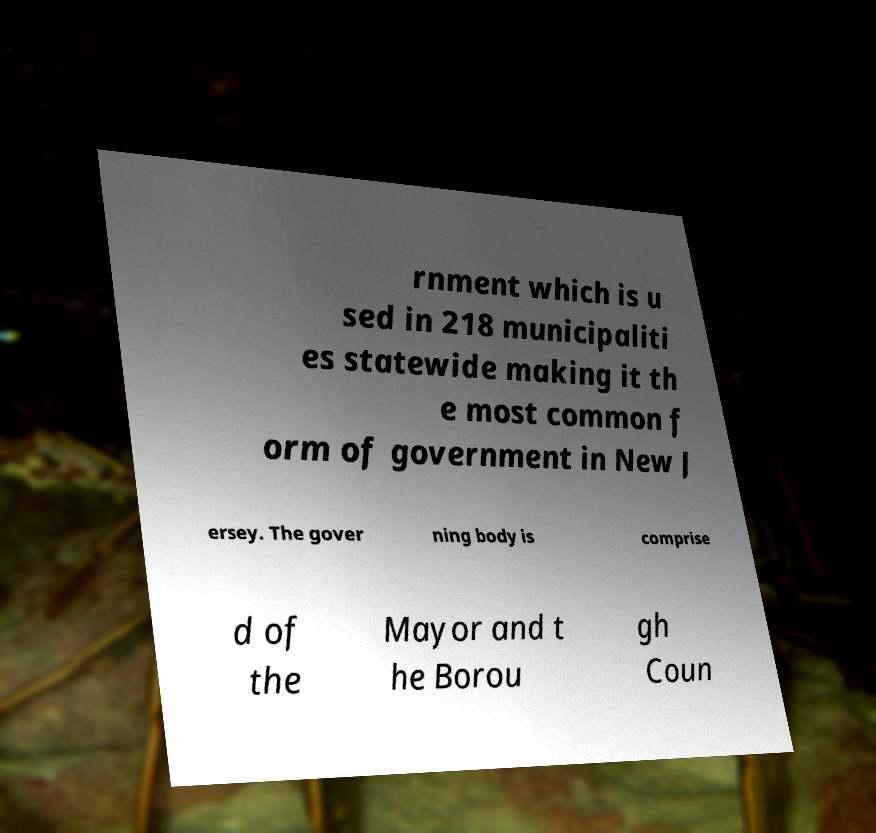Please identify and transcribe the text found in this image. rnment which is u sed in 218 municipaliti es statewide making it th e most common f orm of government in New J ersey. The gover ning body is comprise d of the Mayor and t he Borou gh Coun 